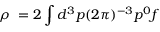Convert formula to latex. <formula><loc_0><loc_0><loc_500><loc_500>\rho \ = 2 \int d ^ { 3 } p ( 2 \pi ) ^ { - 3 } p ^ { 0 } f</formula> 